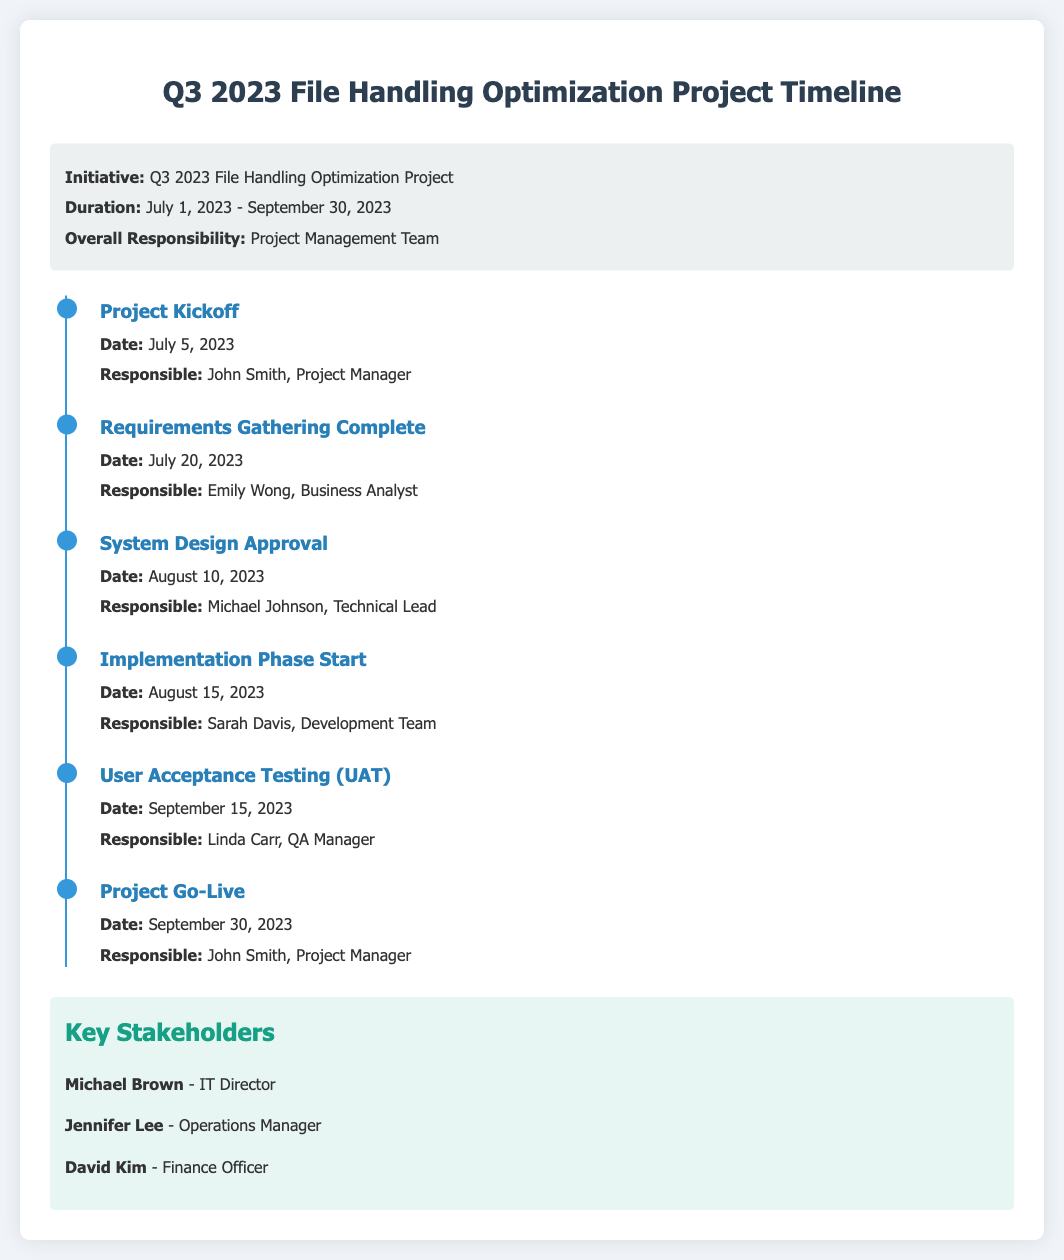What is the duration of the project? The duration is stated in the project info section, which indicates it is from July 1, 2023 to September 30, 2023.
Answer: July 1, 2023 - September 30, 2023 Who is responsible for the Project Kickoff? The responsible person for the Project Kickoff is mentioned under the milestone details in the timeline.
Answer: John Smith, Project Manager What date does the User Acceptance Testing (UAT) occur? The specific date for UAT is listed in the milestone timeline.
Answer: September 15, 2023 Which milestone precedes the System Design Approval? The order of milestones shows which comes first in the timeline.
Answer: Requirements Gathering Complete Who is the QA Manager responsible for User Acceptance Testing? The name and role responsible for UAT is directly stated in the corresponding milestone.
Answer: Linda Carr What is the last milestone before the Project Go-Live? The timeline shows the milestones in sequence, identifying which comes before Go-Live.
Answer: User Acceptance Testing (UAT) How many key stakeholders are mentioned? The number of stakeholders can be counted from the key stakeholders section of the document.
Answer: Three Which team is responsible for the Implementation Phase? The responsible personnel for the Implementation Phase is indicated in the milestone section.
Answer: Sarah Davis, Development Team 